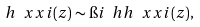<formula> <loc_0><loc_0><loc_500><loc_500>h \ x x i ( z ) \sim \i i \ h h \ x x i ( z ) ,</formula> 